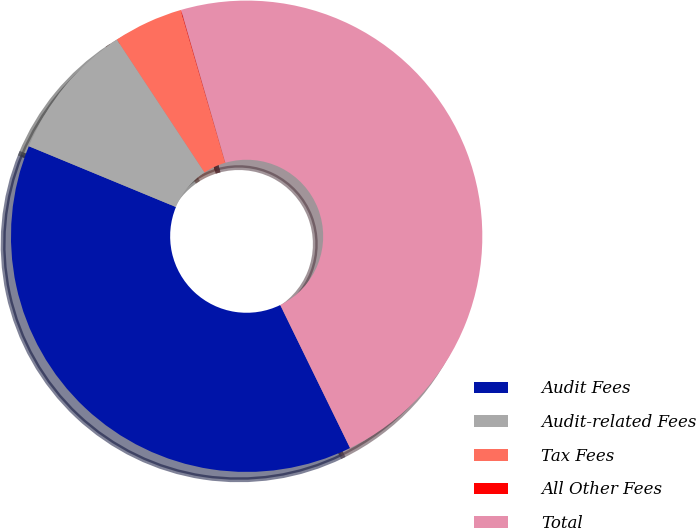Convert chart to OTSL. <chart><loc_0><loc_0><loc_500><loc_500><pie_chart><fcel>Audit Fees<fcel>Audit-related Fees<fcel>Tax Fees<fcel>All Other Fees<fcel>Total<nl><fcel>38.47%<fcel>9.48%<fcel>4.76%<fcel>0.04%<fcel>47.25%<nl></chart> 